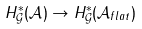Convert formula to latex. <formula><loc_0><loc_0><loc_500><loc_500>H ^ { * } _ { \mathcal { G } } ( \mathcal { A } ) \rightarrow H ^ { * } _ { \mathcal { G } } ( \mathcal { A } _ { f l a t } )</formula> 